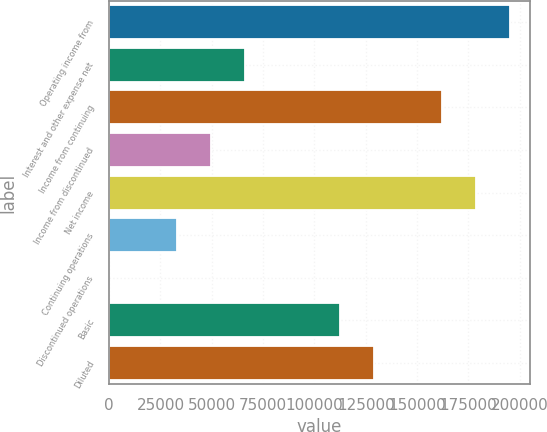Convert chart. <chart><loc_0><loc_0><loc_500><loc_500><bar_chart><fcel>Operating income from<fcel>Interest and other expense net<fcel>Income from continuing<fcel>Income from discontinued<fcel>Net income<fcel>Continuing operations<fcel>Discontinued operations<fcel>Basic<fcel>Diluted<nl><fcel>195096<fcel>66002.9<fcel>162095<fcel>49502.3<fcel>178596<fcel>33001.6<fcel>0.25<fcel>112593<fcel>129094<nl></chart> 